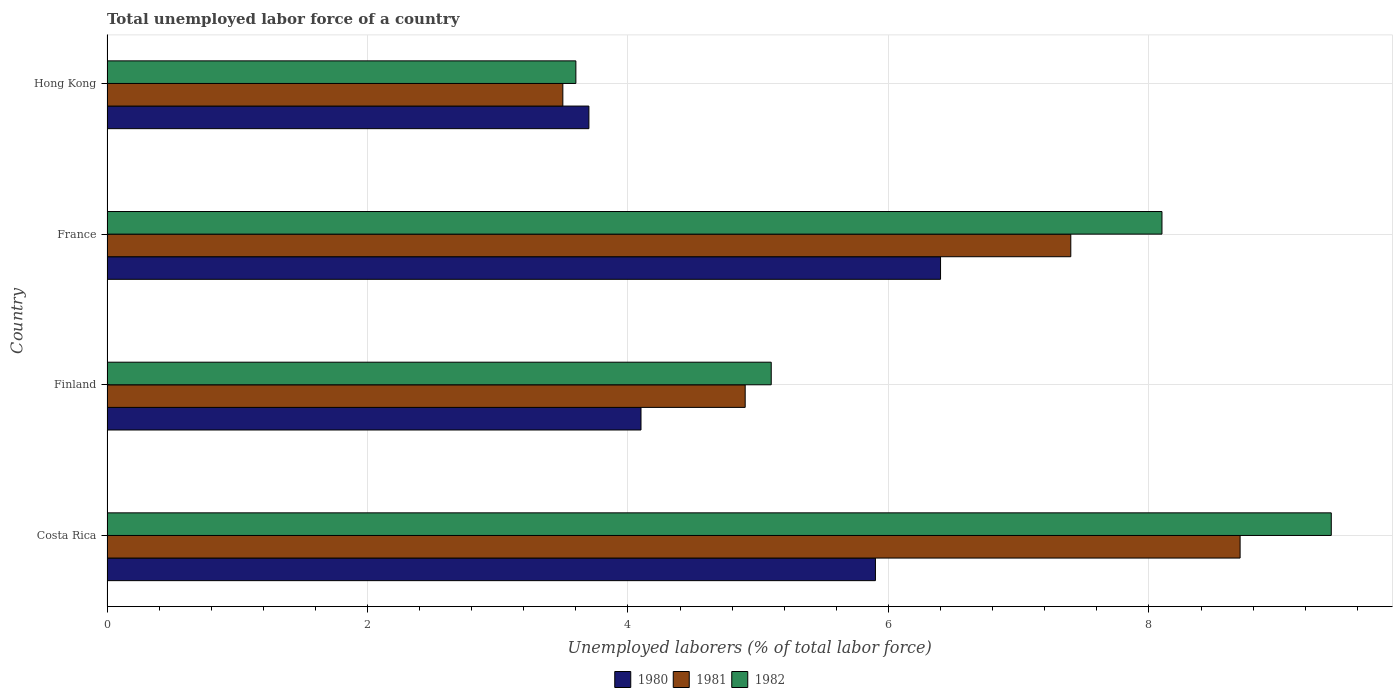How many groups of bars are there?
Your response must be concise. 4. Are the number of bars per tick equal to the number of legend labels?
Ensure brevity in your answer.  Yes. Are the number of bars on each tick of the Y-axis equal?
Ensure brevity in your answer.  Yes. How many bars are there on the 4th tick from the top?
Keep it short and to the point. 3. How many bars are there on the 2nd tick from the bottom?
Your answer should be compact. 3. In how many cases, is the number of bars for a given country not equal to the number of legend labels?
Keep it short and to the point. 0. What is the total unemployed labor force in 1982 in Costa Rica?
Your answer should be compact. 9.4. Across all countries, what is the maximum total unemployed labor force in 1982?
Keep it short and to the point. 9.4. Across all countries, what is the minimum total unemployed labor force in 1980?
Provide a succinct answer. 3.7. In which country was the total unemployed labor force in 1980 maximum?
Provide a succinct answer. France. In which country was the total unemployed labor force in 1982 minimum?
Offer a terse response. Hong Kong. What is the total total unemployed labor force in 1982 in the graph?
Ensure brevity in your answer.  26.2. What is the difference between the total unemployed labor force in 1981 in Costa Rica and that in Hong Kong?
Provide a short and direct response. 5.2. What is the difference between the total unemployed labor force in 1981 in Costa Rica and the total unemployed labor force in 1982 in Finland?
Provide a succinct answer. 3.6. What is the average total unemployed labor force in 1981 per country?
Make the answer very short. 6.12. What is the difference between the total unemployed labor force in 1982 and total unemployed labor force in 1981 in Finland?
Provide a succinct answer. 0.2. In how many countries, is the total unemployed labor force in 1981 greater than 7.6 %?
Your response must be concise. 1. What is the ratio of the total unemployed labor force in 1980 in Costa Rica to that in France?
Make the answer very short. 0.92. Is the total unemployed labor force in 1980 in France less than that in Hong Kong?
Offer a terse response. No. Is the difference between the total unemployed labor force in 1982 in Costa Rica and Finland greater than the difference between the total unemployed labor force in 1981 in Costa Rica and Finland?
Provide a short and direct response. Yes. What is the difference between the highest and the second highest total unemployed labor force in 1982?
Provide a succinct answer. 1.3. What is the difference between the highest and the lowest total unemployed labor force in 1980?
Your answer should be compact. 2.7. In how many countries, is the total unemployed labor force in 1980 greater than the average total unemployed labor force in 1980 taken over all countries?
Your response must be concise. 2. Is the sum of the total unemployed labor force in 1981 in Costa Rica and Hong Kong greater than the maximum total unemployed labor force in 1982 across all countries?
Provide a short and direct response. Yes. How many countries are there in the graph?
Your answer should be compact. 4. Does the graph contain grids?
Your answer should be compact. Yes. Where does the legend appear in the graph?
Your answer should be compact. Bottom center. How are the legend labels stacked?
Your answer should be compact. Horizontal. What is the title of the graph?
Your answer should be compact. Total unemployed labor force of a country. Does "1992" appear as one of the legend labels in the graph?
Your answer should be compact. No. What is the label or title of the X-axis?
Offer a very short reply. Unemployed laborers (% of total labor force). What is the Unemployed laborers (% of total labor force) in 1980 in Costa Rica?
Provide a short and direct response. 5.9. What is the Unemployed laborers (% of total labor force) in 1981 in Costa Rica?
Offer a very short reply. 8.7. What is the Unemployed laborers (% of total labor force) in 1982 in Costa Rica?
Your answer should be very brief. 9.4. What is the Unemployed laborers (% of total labor force) of 1980 in Finland?
Offer a terse response. 4.1. What is the Unemployed laborers (% of total labor force) in 1981 in Finland?
Your answer should be very brief. 4.9. What is the Unemployed laborers (% of total labor force) of 1982 in Finland?
Give a very brief answer. 5.1. What is the Unemployed laborers (% of total labor force) in 1980 in France?
Give a very brief answer. 6.4. What is the Unemployed laborers (% of total labor force) of 1981 in France?
Provide a succinct answer. 7.4. What is the Unemployed laborers (% of total labor force) of 1982 in France?
Offer a terse response. 8.1. What is the Unemployed laborers (% of total labor force) in 1980 in Hong Kong?
Your answer should be very brief. 3.7. What is the Unemployed laborers (% of total labor force) in 1981 in Hong Kong?
Ensure brevity in your answer.  3.5. What is the Unemployed laborers (% of total labor force) of 1982 in Hong Kong?
Make the answer very short. 3.6. Across all countries, what is the maximum Unemployed laborers (% of total labor force) of 1980?
Provide a succinct answer. 6.4. Across all countries, what is the maximum Unemployed laborers (% of total labor force) of 1981?
Keep it short and to the point. 8.7. Across all countries, what is the maximum Unemployed laborers (% of total labor force) in 1982?
Provide a short and direct response. 9.4. Across all countries, what is the minimum Unemployed laborers (% of total labor force) in 1980?
Make the answer very short. 3.7. Across all countries, what is the minimum Unemployed laborers (% of total labor force) of 1982?
Offer a terse response. 3.6. What is the total Unemployed laborers (% of total labor force) of 1980 in the graph?
Provide a succinct answer. 20.1. What is the total Unemployed laborers (% of total labor force) in 1982 in the graph?
Provide a short and direct response. 26.2. What is the difference between the Unemployed laborers (% of total labor force) in 1980 in Costa Rica and that in Finland?
Provide a short and direct response. 1.8. What is the difference between the Unemployed laborers (% of total labor force) of 1981 in Costa Rica and that in Finland?
Your answer should be very brief. 3.8. What is the difference between the Unemployed laborers (% of total labor force) of 1980 in Costa Rica and that in France?
Your answer should be compact. -0.5. What is the difference between the Unemployed laborers (% of total labor force) in 1981 in Costa Rica and that in France?
Offer a terse response. 1.3. What is the difference between the Unemployed laborers (% of total labor force) in 1982 in Costa Rica and that in France?
Ensure brevity in your answer.  1.3. What is the difference between the Unemployed laborers (% of total labor force) in 1980 in Costa Rica and that in Hong Kong?
Your response must be concise. 2.2. What is the difference between the Unemployed laborers (% of total labor force) of 1981 in Costa Rica and that in Hong Kong?
Provide a succinct answer. 5.2. What is the difference between the Unemployed laborers (% of total labor force) in 1982 in Costa Rica and that in Hong Kong?
Make the answer very short. 5.8. What is the difference between the Unemployed laborers (% of total labor force) in 1981 in Finland and that in Hong Kong?
Provide a short and direct response. 1.4. What is the difference between the Unemployed laborers (% of total labor force) in 1982 in Finland and that in Hong Kong?
Provide a succinct answer. 1.5. What is the difference between the Unemployed laborers (% of total labor force) of 1981 in France and that in Hong Kong?
Offer a very short reply. 3.9. What is the difference between the Unemployed laborers (% of total labor force) in 1982 in France and that in Hong Kong?
Your answer should be very brief. 4.5. What is the difference between the Unemployed laborers (% of total labor force) in 1980 in Costa Rica and the Unemployed laborers (% of total labor force) in 1981 in Finland?
Your response must be concise. 1. What is the difference between the Unemployed laborers (% of total labor force) in 1980 in Finland and the Unemployed laborers (% of total labor force) in 1982 in France?
Your answer should be compact. -4. What is the difference between the Unemployed laborers (% of total labor force) in 1981 in Finland and the Unemployed laborers (% of total labor force) in 1982 in France?
Ensure brevity in your answer.  -3.2. What is the difference between the Unemployed laborers (% of total labor force) of 1980 in Finland and the Unemployed laborers (% of total labor force) of 1982 in Hong Kong?
Make the answer very short. 0.5. What is the difference between the Unemployed laborers (% of total labor force) in 1981 in Finland and the Unemployed laborers (% of total labor force) in 1982 in Hong Kong?
Make the answer very short. 1.3. What is the difference between the Unemployed laborers (% of total labor force) in 1980 in France and the Unemployed laborers (% of total labor force) in 1982 in Hong Kong?
Give a very brief answer. 2.8. What is the difference between the Unemployed laborers (% of total labor force) of 1981 in France and the Unemployed laborers (% of total labor force) of 1982 in Hong Kong?
Offer a very short reply. 3.8. What is the average Unemployed laborers (% of total labor force) in 1980 per country?
Keep it short and to the point. 5.03. What is the average Unemployed laborers (% of total labor force) of 1981 per country?
Keep it short and to the point. 6.12. What is the average Unemployed laborers (% of total labor force) in 1982 per country?
Offer a very short reply. 6.55. What is the difference between the Unemployed laborers (% of total labor force) of 1981 and Unemployed laborers (% of total labor force) of 1982 in Finland?
Ensure brevity in your answer.  -0.2. What is the difference between the Unemployed laborers (% of total labor force) of 1981 and Unemployed laborers (% of total labor force) of 1982 in Hong Kong?
Keep it short and to the point. -0.1. What is the ratio of the Unemployed laborers (% of total labor force) in 1980 in Costa Rica to that in Finland?
Your response must be concise. 1.44. What is the ratio of the Unemployed laborers (% of total labor force) in 1981 in Costa Rica to that in Finland?
Keep it short and to the point. 1.78. What is the ratio of the Unemployed laborers (% of total labor force) in 1982 in Costa Rica to that in Finland?
Keep it short and to the point. 1.84. What is the ratio of the Unemployed laborers (% of total labor force) in 1980 in Costa Rica to that in France?
Ensure brevity in your answer.  0.92. What is the ratio of the Unemployed laborers (% of total labor force) in 1981 in Costa Rica to that in France?
Ensure brevity in your answer.  1.18. What is the ratio of the Unemployed laborers (% of total labor force) in 1982 in Costa Rica to that in France?
Provide a succinct answer. 1.16. What is the ratio of the Unemployed laborers (% of total labor force) of 1980 in Costa Rica to that in Hong Kong?
Give a very brief answer. 1.59. What is the ratio of the Unemployed laborers (% of total labor force) of 1981 in Costa Rica to that in Hong Kong?
Make the answer very short. 2.49. What is the ratio of the Unemployed laborers (% of total labor force) in 1982 in Costa Rica to that in Hong Kong?
Ensure brevity in your answer.  2.61. What is the ratio of the Unemployed laborers (% of total labor force) of 1980 in Finland to that in France?
Offer a very short reply. 0.64. What is the ratio of the Unemployed laborers (% of total labor force) of 1981 in Finland to that in France?
Offer a terse response. 0.66. What is the ratio of the Unemployed laborers (% of total labor force) in 1982 in Finland to that in France?
Ensure brevity in your answer.  0.63. What is the ratio of the Unemployed laborers (% of total labor force) of 1980 in Finland to that in Hong Kong?
Keep it short and to the point. 1.11. What is the ratio of the Unemployed laborers (% of total labor force) in 1981 in Finland to that in Hong Kong?
Make the answer very short. 1.4. What is the ratio of the Unemployed laborers (% of total labor force) in 1982 in Finland to that in Hong Kong?
Offer a very short reply. 1.42. What is the ratio of the Unemployed laborers (% of total labor force) in 1980 in France to that in Hong Kong?
Your answer should be very brief. 1.73. What is the ratio of the Unemployed laborers (% of total labor force) in 1981 in France to that in Hong Kong?
Your answer should be very brief. 2.11. What is the ratio of the Unemployed laborers (% of total labor force) of 1982 in France to that in Hong Kong?
Provide a short and direct response. 2.25. What is the difference between the highest and the lowest Unemployed laborers (% of total labor force) of 1981?
Give a very brief answer. 5.2. 